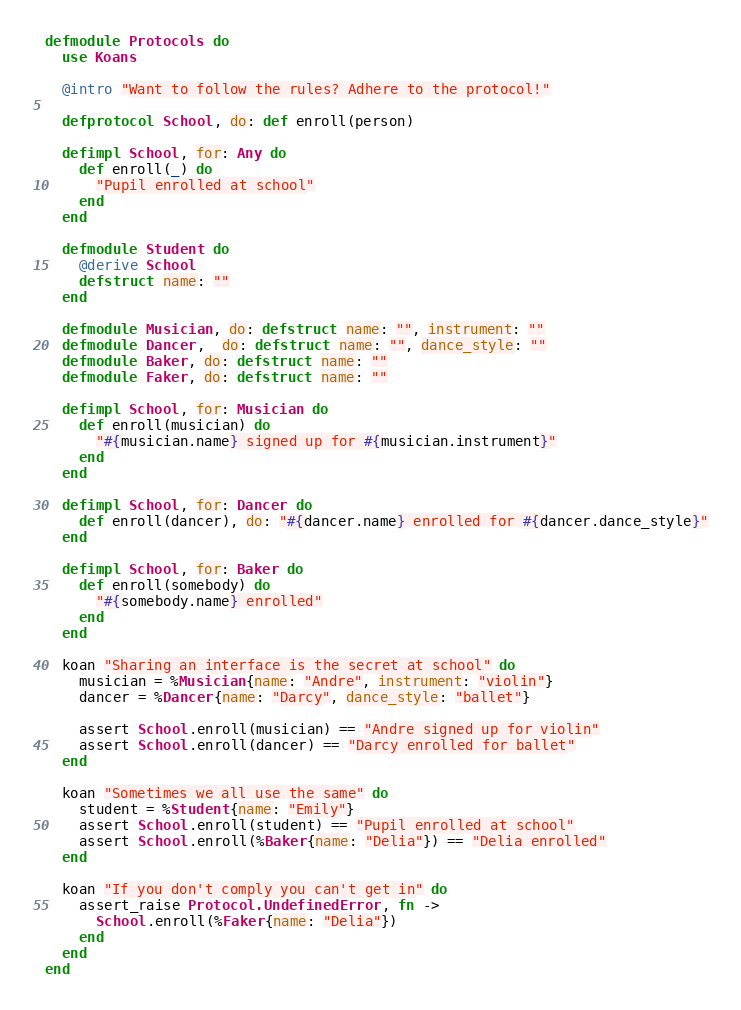Convert code to text. <code><loc_0><loc_0><loc_500><loc_500><_Elixir_>defmodule Protocols do
  use Koans

  @intro "Want to follow the rules? Adhere to the protocol!"

  defprotocol School, do: def enroll(person)

  defimpl School, for: Any do
    def enroll(_) do
      "Pupil enrolled at school"
    end
  end

  defmodule Student do
    @derive School
    defstruct name: ""
  end

  defmodule Musician, do: defstruct name: "", instrument: ""
  defmodule Dancer,  do: defstruct name: "", dance_style: ""
  defmodule Baker, do: defstruct name: ""
  defmodule Faker, do: defstruct name: ""

  defimpl School, for: Musician do
    def enroll(musician) do
      "#{musician.name} signed up for #{musician.instrument}"
    end
  end

  defimpl School, for: Dancer do
    def enroll(dancer), do: "#{dancer.name} enrolled for #{dancer.dance_style}"
  end

  defimpl School, for: Baker do
    def enroll(somebody) do
      "#{somebody.name} enrolled"
    end
  end

  koan "Sharing an interface is the secret at school" do
    musician = %Musician{name: "Andre", instrument: "violin"}
    dancer = %Dancer{name: "Darcy", dance_style: "ballet"}

    assert School.enroll(musician) == "Andre signed up for violin"
    assert School.enroll(dancer) == "Darcy enrolled for ballet"
  end

  koan "Sometimes we all use the same" do
    student = %Student{name: "Emily"}
    assert School.enroll(student) == "Pupil enrolled at school"
    assert School.enroll(%Baker{name: "Delia"}) == "Delia enrolled"
  end

  koan "If you don't comply you can't get in" do
    assert_raise Protocol.UndefinedError, fn ->
      School.enroll(%Faker{name: "Delia"})
    end
  end
end
</code> 